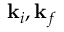Convert formula to latex. <formula><loc_0><loc_0><loc_500><loc_500>{ \mathbf k } _ { i } , { \mathbf k } _ { f }</formula> 